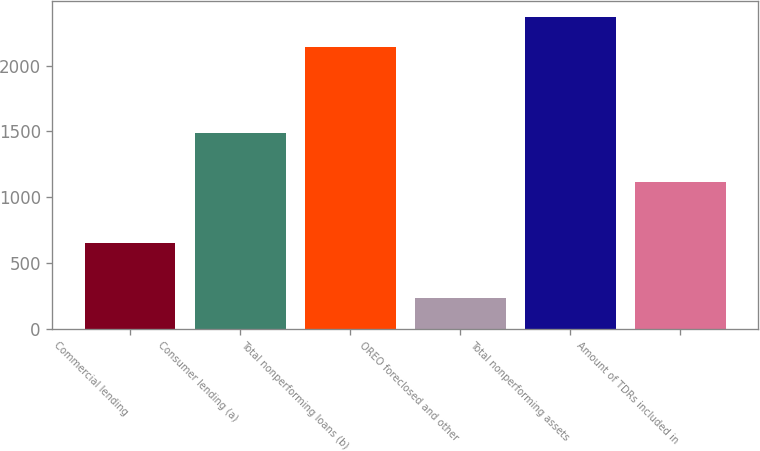<chart> <loc_0><loc_0><loc_500><loc_500><bar_chart><fcel>Commercial lending<fcel>Consumer lending (a)<fcel>Total nonperforming loans (b)<fcel>OREO foreclosed and other<fcel>Total nonperforming assets<fcel>Amount of TDRs included in<nl><fcel>655<fcel>1489<fcel>2144<fcel>230<fcel>2374<fcel>1112<nl></chart> 